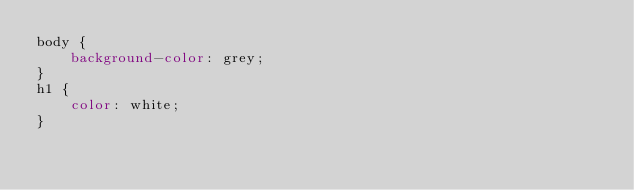<code> <loc_0><loc_0><loc_500><loc_500><_CSS_>body {
    background-color: grey;
}
h1 {
    color: white;
}</code> 